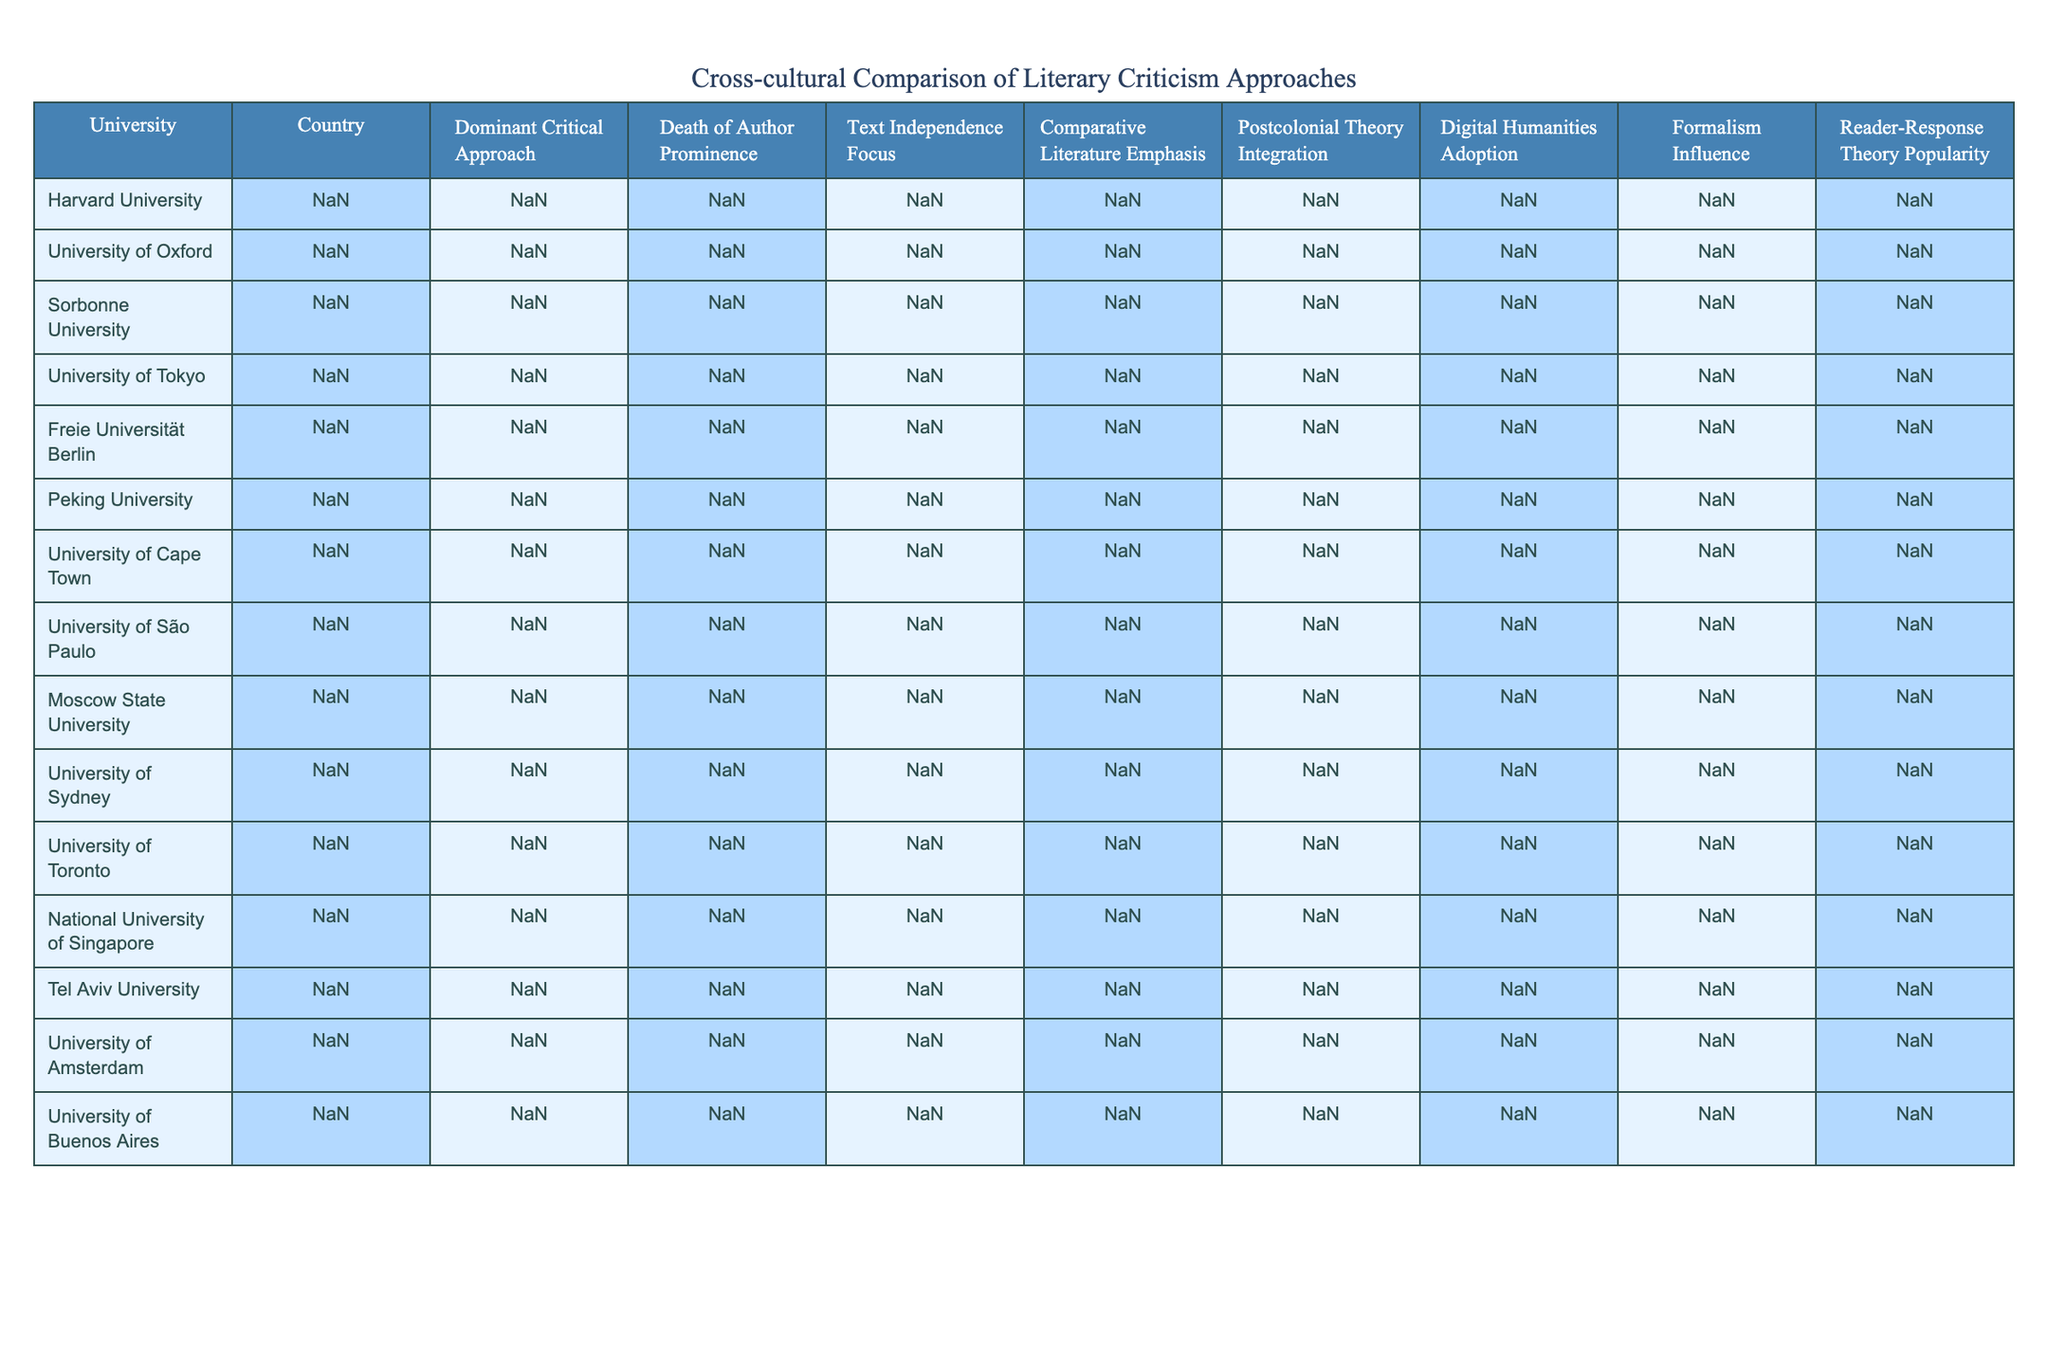What is the dominant critical approach at Harvard University? From the table, we can see that the row corresponding to Harvard University lists "New Criticism" as the dominant critical approach.
Answer: New Criticism Which university in the UK has a high focus on text independence? The table lists the University of Oxford as having a "High" level of focus on text independence, which applies to the UK.
Answer: University of Oxford What is the relationship between postcolonial theory integration and reader-response theory popularity in Brazilian literary criticism? The table shows that the University of São Paulo in Brazil has a "High" integration of postcolonial theory but a "Very Low" popularity for reader-response theory, indicating a disconnect between these two approaches at this university.
Answer: They have a disconnect Which country has the lowest focus on text independence? By reviewing the table, Peking University in China is noted to have a "Low" focus on text independence, making it the lowest among the listed universities.
Answer: China How many universities emphasize both comparative literature and postcolonial theory integration? Analyzing the table, the University of Cape Town and the University of Buenos Aires both have "High" levels for comparative literature emphasis and "Very High" for postcolonial theory integration. Thus, there are 2 universities with this emphasis.
Answer: 2 Is reader-response theory more popular in the USA than in Japan? The table indicates that Harvard University in the USA has a "Low" popularity for reader-response theory while the University of Tokyo in Japan also has a "Low" popularity. Therefore, they are equal, and the answer is no.
Answer: No What is the average prominence of the death of the author across the listed universities? To calculate the average prominence of the death of the author, we assign numerical values (Very High = 4, High = 3, Moderate = 2, Low = 1) and sum them: (3 + 2 + 4 + 1 + 3 + 1 + 2 + 3 + 4 + 3 + 2 + 1 + 2 + 3)/14 = 2.43, resulting in an average of approximately 2.43.
Answer: Approximately 2.43 Which critical approach is most prevalent across the universities listed? Upon reviewing the table, we note that "High" is the most common rating for the critical approaches, especially in the areas of New Criticism, Historicism, and several others, indicating a trend. This suggests that various critical approaches closely align in prevalence.
Answer: High Which university integrates digital humanities the most? The table indicates that National University of Singapore has "Very High" adoption of digital humanities, making it the standout in this category.
Answer: National University of Singapore Do any universities focus on formalism while also having high text independence? Checking the table shows that Moscow State University has a "Very High" popularity for formalism, but it only rates "Moderate" for text independence. Hence, there are no universities that meet both criteria.
Answer: No 